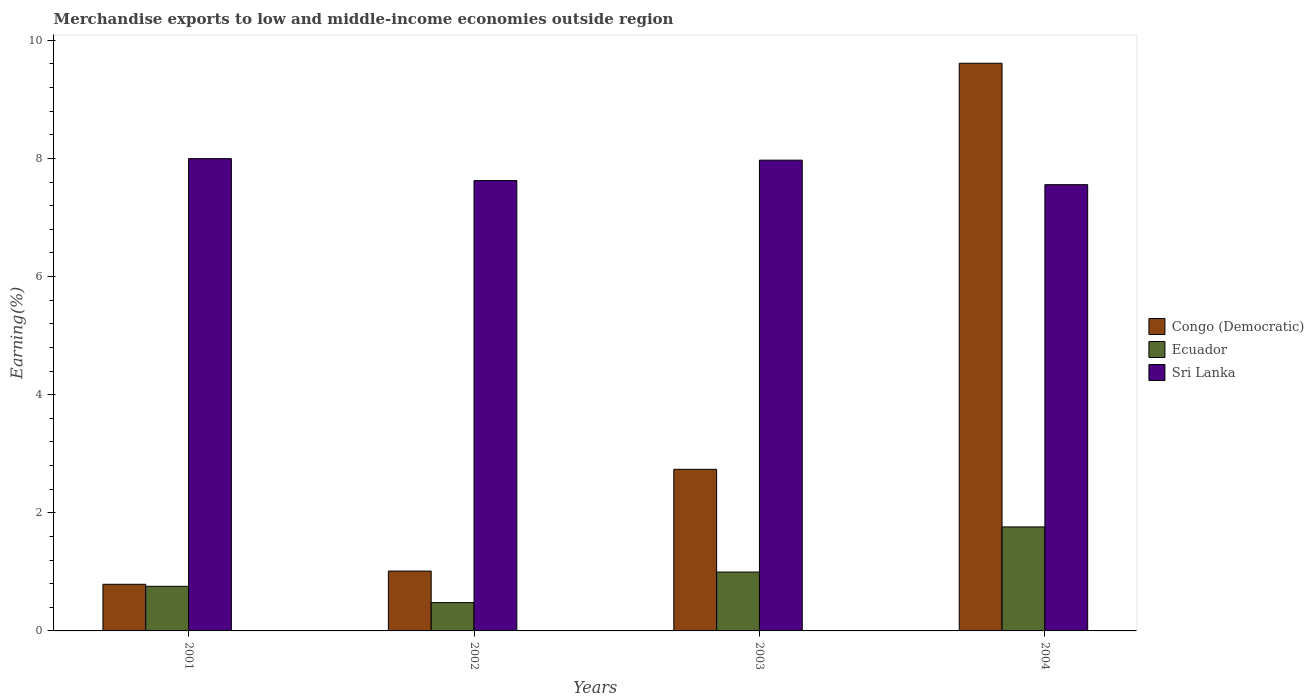How many different coloured bars are there?
Your answer should be very brief. 3. How many groups of bars are there?
Make the answer very short. 4. Are the number of bars per tick equal to the number of legend labels?
Offer a terse response. Yes. Are the number of bars on each tick of the X-axis equal?
Make the answer very short. Yes. How many bars are there on the 2nd tick from the right?
Offer a very short reply. 3. What is the label of the 4th group of bars from the left?
Your answer should be compact. 2004. What is the percentage of amount earned from merchandise exports in Sri Lanka in 2001?
Offer a terse response. 8. Across all years, what is the maximum percentage of amount earned from merchandise exports in Congo (Democratic)?
Provide a short and direct response. 9.61. Across all years, what is the minimum percentage of amount earned from merchandise exports in Sri Lanka?
Offer a very short reply. 7.56. In which year was the percentage of amount earned from merchandise exports in Congo (Democratic) maximum?
Your answer should be very brief. 2004. In which year was the percentage of amount earned from merchandise exports in Sri Lanka minimum?
Keep it short and to the point. 2004. What is the total percentage of amount earned from merchandise exports in Congo (Democratic) in the graph?
Your response must be concise. 14.15. What is the difference between the percentage of amount earned from merchandise exports in Sri Lanka in 2001 and that in 2002?
Provide a short and direct response. 0.37. What is the difference between the percentage of amount earned from merchandise exports in Sri Lanka in 2002 and the percentage of amount earned from merchandise exports in Congo (Democratic) in 2004?
Your answer should be compact. -1.99. What is the average percentage of amount earned from merchandise exports in Sri Lanka per year?
Offer a terse response. 7.79. In the year 2001, what is the difference between the percentage of amount earned from merchandise exports in Congo (Democratic) and percentage of amount earned from merchandise exports in Ecuador?
Ensure brevity in your answer.  0.03. What is the ratio of the percentage of amount earned from merchandise exports in Congo (Democratic) in 2001 to that in 2002?
Your answer should be very brief. 0.78. Is the difference between the percentage of amount earned from merchandise exports in Congo (Democratic) in 2001 and 2002 greater than the difference between the percentage of amount earned from merchandise exports in Ecuador in 2001 and 2002?
Your response must be concise. No. What is the difference between the highest and the second highest percentage of amount earned from merchandise exports in Sri Lanka?
Provide a succinct answer. 0.03. What is the difference between the highest and the lowest percentage of amount earned from merchandise exports in Sri Lanka?
Your answer should be compact. 0.44. What does the 3rd bar from the left in 2001 represents?
Provide a short and direct response. Sri Lanka. What does the 2nd bar from the right in 2002 represents?
Your response must be concise. Ecuador. Are all the bars in the graph horizontal?
Keep it short and to the point. No. How many years are there in the graph?
Your response must be concise. 4. What is the difference between two consecutive major ticks on the Y-axis?
Give a very brief answer. 2. Does the graph contain grids?
Make the answer very short. No. Where does the legend appear in the graph?
Provide a succinct answer. Center right. How many legend labels are there?
Make the answer very short. 3. What is the title of the graph?
Your answer should be very brief. Merchandise exports to low and middle-income economies outside region. Does "Afghanistan" appear as one of the legend labels in the graph?
Make the answer very short. No. What is the label or title of the X-axis?
Provide a short and direct response. Years. What is the label or title of the Y-axis?
Make the answer very short. Earning(%). What is the Earning(%) of Congo (Democratic) in 2001?
Give a very brief answer. 0.79. What is the Earning(%) in Ecuador in 2001?
Offer a terse response. 0.76. What is the Earning(%) of Sri Lanka in 2001?
Offer a very short reply. 8. What is the Earning(%) in Congo (Democratic) in 2002?
Give a very brief answer. 1.01. What is the Earning(%) in Ecuador in 2002?
Your response must be concise. 0.48. What is the Earning(%) in Sri Lanka in 2002?
Offer a terse response. 7.63. What is the Earning(%) of Congo (Democratic) in 2003?
Your answer should be compact. 2.74. What is the Earning(%) of Ecuador in 2003?
Offer a terse response. 1. What is the Earning(%) of Sri Lanka in 2003?
Provide a short and direct response. 7.97. What is the Earning(%) of Congo (Democratic) in 2004?
Your response must be concise. 9.61. What is the Earning(%) in Ecuador in 2004?
Your answer should be very brief. 1.76. What is the Earning(%) in Sri Lanka in 2004?
Offer a terse response. 7.56. Across all years, what is the maximum Earning(%) of Congo (Democratic)?
Give a very brief answer. 9.61. Across all years, what is the maximum Earning(%) of Ecuador?
Your answer should be compact. 1.76. Across all years, what is the maximum Earning(%) in Sri Lanka?
Keep it short and to the point. 8. Across all years, what is the minimum Earning(%) of Congo (Democratic)?
Keep it short and to the point. 0.79. Across all years, what is the minimum Earning(%) of Ecuador?
Provide a succinct answer. 0.48. Across all years, what is the minimum Earning(%) of Sri Lanka?
Your response must be concise. 7.56. What is the total Earning(%) in Congo (Democratic) in the graph?
Your response must be concise. 14.15. What is the total Earning(%) of Ecuador in the graph?
Provide a short and direct response. 3.99. What is the total Earning(%) of Sri Lanka in the graph?
Your answer should be compact. 31.15. What is the difference between the Earning(%) in Congo (Democratic) in 2001 and that in 2002?
Offer a terse response. -0.22. What is the difference between the Earning(%) of Ecuador in 2001 and that in 2002?
Your answer should be compact. 0.28. What is the difference between the Earning(%) in Sri Lanka in 2001 and that in 2002?
Your response must be concise. 0.37. What is the difference between the Earning(%) in Congo (Democratic) in 2001 and that in 2003?
Offer a terse response. -1.95. What is the difference between the Earning(%) in Ecuador in 2001 and that in 2003?
Offer a terse response. -0.24. What is the difference between the Earning(%) in Sri Lanka in 2001 and that in 2003?
Your answer should be very brief. 0.03. What is the difference between the Earning(%) of Congo (Democratic) in 2001 and that in 2004?
Offer a very short reply. -8.82. What is the difference between the Earning(%) in Ecuador in 2001 and that in 2004?
Make the answer very short. -1.01. What is the difference between the Earning(%) in Sri Lanka in 2001 and that in 2004?
Your answer should be very brief. 0.44. What is the difference between the Earning(%) in Congo (Democratic) in 2002 and that in 2003?
Your answer should be compact. -1.72. What is the difference between the Earning(%) in Ecuador in 2002 and that in 2003?
Your response must be concise. -0.52. What is the difference between the Earning(%) of Sri Lanka in 2002 and that in 2003?
Provide a succinct answer. -0.35. What is the difference between the Earning(%) of Congo (Democratic) in 2002 and that in 2004?
Offer a terse response. -8.6. What is the difference between the Earning(%) in Ecuador in 2002 and that in 2004?
Provide a succinct answer. -1.28. What is the difference between the Earning(%) in Sri Lanka in 2002 and that in 2004?
Your answer should be compact. 0.07. What is the difference between the Earning(%) of Congo (Democratic) in 2003 and that in 2004?
Your answer should be compact. -6.88. What is the difference between the Earning(%) in Ecuador in 2003 and that in 2004?
Give a very brief answer. -0.76. What is the difference between the Earning(%) in Sri Lanka in 2003 and that in 2004?
Keep it short and to the point. 0.41. What is the difference between the Earning(%) of Congo (Democratic) in 2001 and the Earning(%) of Ecuador in 2002?
Provide a succinct answer. 0.31. What is the difference between the Earning(%) of Congo (Democratic) in 2001 and the Earning(%) of Sri Lanka in 2002?
Provide a succinct answer. -6.84. What is the difference between the Earning(%) in Ecuador in 2001 and the Earning(%) in Sri Lanka in 2002?
Your response must be concise. -6.87. What is the difference between the Earning(%) in Congo (Democratic) in 2001 and the Earning(%) in Ecuador in 2003?
Ensure brevity in your answer.  -0.21. What is the difference between the Earning(%) of Congo (Democratic) in 2001 and the Earning(%) of Sri Lanka in 2003?
Your response must be concise. -7.18. What is the difference between the Earning(%) in Ecuador in 2001 and the Earning(%) in Sri Lanka in 2003?
Provide a short and direct response. -7.22. What is the difference between the Earning(%) of Congo (Democratic) in 2001 and the Earning(%) of Ecuador in 2004?
Ensure brevity in your answer.  -0.97. What is the difference between the Earning(%) in Congo (Democratic) in 2001 and the Earning(%) in Sri Lanka in 2004?
Provide a succinct answer. -6.77. What is the difference between the Earning(%) in Ecuador in 2001 and the Earning(%) in Sri Lanka in 2004?
Your answer should be very brief. -6.8. What is the difference between the Earning(%) of Congo (Democratic) in 2002 and the Earning(%) of Ecuador in 2003?
Keep it short and to the point. 0.02. What is the difference between the Earning(%) of Congo (Democratic) in 2002 and the Earning(%) of Sri Lanka in 2003?
Your response must be concise. -6.96. What is the difference between the Earning(%) in Ecuador in 2002 and the Earning(%) in Sri Lanka in 2003?
Your response must be concise. -7.49. What is the difference between the Earning(%) of Congo (Democratic) in 2002 and the Earning(%) of Ecuador in 2004?
Offer a terse response. -0.75. What is the difference between the Earning(%) in Congo (Democratic) in 2002 and the Earning(%) in Sri Lanka in 2004?
Offer a very short reply. -6.54. What is the difference between the Earning(%) of Ecuador in 2002 and the Earning(%) of Sri Lanka in 2004?
Provide a short and direct response. -7.08. What is the difference between the Earning(%) of Congo (Democratic) in 2003 and the Earning(%) of Ecuador in 2004?
Offer a very short reply. 0.98. What is the difference between the Earning(%) of Congo (Democratic) in 2003 and the Earning(%) of Sri Lanka in 2004?
Give a very brief answer. -4.82. What is the difference between the Earning(%) of Ecuador in 2003 and the Earning(%) of Sri Lanka in 2004?
Your response must be concise. -6.56. What is the average Earning(%) of Congo (Democratic) per year?
Make the answer very short. 3.54. What is the average Earning(%) in Sri Lanka per year?
Make the answer very short. 7.79. In the year 2001, what is the difference between the Earning(%) of Congo (Democratic) and Earning(%) of Ecuador?
Ensure brevity in your answer.  0.03. In the year 2001, what is the difference between the Earning(%) of Congo (Democratic) and Earning(%) of Sri Lanka?
Provide a succinct answer. -7.21. In the year 2001, what is the difference between the Earning(%) in Ecuador and Earning(%) in Sri Lanka?
Your answer should be very brief. -7.24. In the year 2002, what is the difference between the Earning(%) of Congo (Democratic) and Earning(%) of Ecuador?
Your answer should be compact. 0.53. In the year 2002, what is the difference between the Earning(%) in Congo (Democratic) and Earning(%) in Sri Lanka?
Your answer should be very brief. -6.61. In the year 2002, what is the difference between the Earning(%) of Ecuador and Earning(%) of Sri Lanka?
Make the answer very short. -7.15. In the year 2003, what is the difference between the Earning(%) of Congo (Democratic) and Earning(%) of Ecuador?
Provide a succinct answer. 1.74. In the year 2003, what is the difference between the Earning(%) of Congo (Democratic) and Earning(%) of Sri Lanka?
Keep it short and to the point. -5.23. In the year 2003, what is the difference between the Earning(%) in Ecuador and Earning(%) in Sri Lanka?
Make the answer very short. -6.97. In the year 2004, what is the difference between the Earning(%) in Congo (Democratic) and Earning(%) in Ecuador?
Offer a terse response. 7.85. In the year 2004, what is the difference between the Earning(%) of Congo (Democratic) and Earning(%) of Sri Lanka?
Your answer should be compact. 2.06. In the year 2004, what is the difference between the Earning(%) of Ecuador and Earning(%) of Sri Lanka?
Your answer should be very brief. -5.8. What is the ratio of the Earning(%) in Congo (Democratic) in 2001 to that in 2002?
Your response must be concise. 0.78. What is the ratio of the Earning(%) in Ecuador in 2001 to that in 2002?
Keep it short and to the point. 1.58. What is the ratio of the Earning(%) in Sri Lanka in 2001 to that in 2002?
Offer a terse response. 1.05. What is the ratio of the Earning(%) in Congo (Democratic) in 2001 to that in 2003?
Your answer should be compact. 0.29. What is the ratio of the Earning(%) in Ecuador in 2001 to that in 2003?
Ensure brevity in your answer.  0.76. What is the ratio of the Earning(%) in Sri Lanka in 2001 to that in 2003?
Your response must be concise. 1. What is the ratio of the Earning(%) of Congo (Democratic) in 2001 to that in 2004?
Offer a very short reply. 0.08. What is the ratio of the Earning(%) in Ecuador in 2001 to that in 2004?
Provide a short and direct response. 0.43. What is the ratio of the Earning(%) in Sri Lanka in 2001 to that in 2004?
Your answer should be compact. 1.06. What is the ratio of the Earning(%) of Congo (Democratic) in 2002 to that in 2003?
Your answer should be very brief. 0.37. What is the ratio of the Earning(%) in Ecuador in 2002 to that in 2003?
Keep it short and to the point. 0.48. What is the ratio of the Earning(%) in Sri Lanka in 2002 to that in 2003?
Provide a succinct answer. 0.96. What is the ratio of the Earning(%) of Congo (Democratic) in 2002 to that in 2004?
Your response must be concise. 0.11. What is the ratio of the Earning(%) of Ecuador in 2002 to that in 2004?
Provide a short and direct response. 0.27. What is the ratio of the Earning(%) of Sri Lanka in 2002 to that in 2004?
Make the answer very short. 1.01. What is the ratio of the Earning(%) in Congo (Democratic) in 2003 to that in 2004?
Offer a very short reply. 0.28. What is the ratio of the Earning(%) of Ecuador in 2003 to that in 2004?
Give a very brief answer. 0.57. What is the ratio of the Earning(%) in Sri Lanka in 2003 to that in 2004?
Keep it short and to the point. 1.05. What is the difference between the highest and the second highest Earning(%) of Congo (Democratic)?
Make the answer very short. 6.88. What is the difference between the highest and the second highest Earning(%) in Ecuador?
Make the answer very short. 0.76. What is the difference between the highest and the second highest Earning(%) in Sri Lanka?
Your response must be concise. 0.03. What is the difference between the highest and the lowest Earning(%) in Congo (Democratic)?
Make the answer very short. 8.82. What is the difference between the highest and the lowest Earning(%) of Ecuador?
Keep it short and to the point. 1.28. What is the difference between the highest and the lowest Earning(%) in Sri Lanka?
Provide a short and direct response. 0.44. 